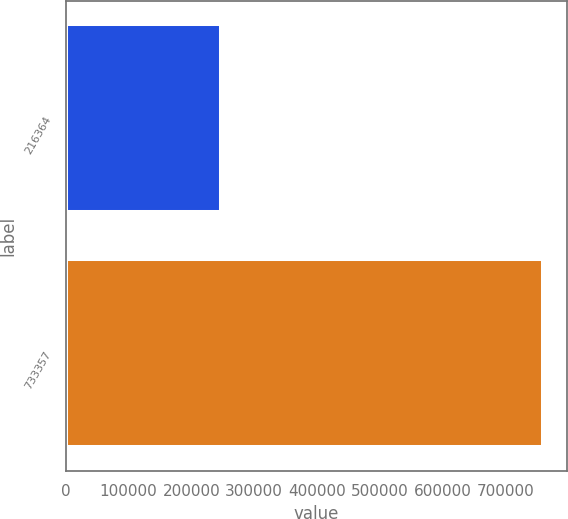<chart> <loc_0><loc_0><loc_500><loc_500><bar_chart><fcel>216364<fcel>733357<nl><fcel>247086<fcel>759876<nl></chart> 